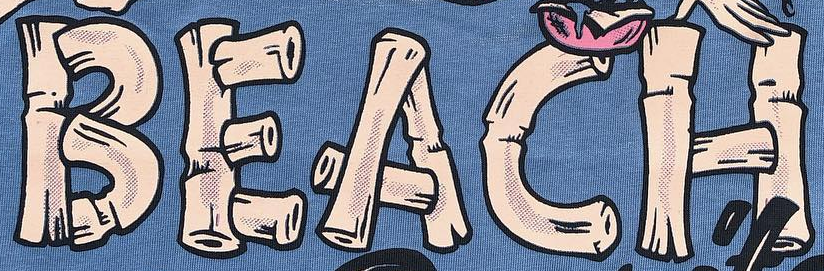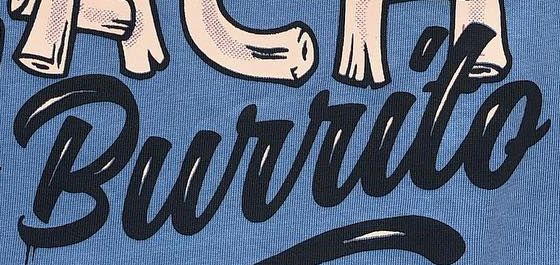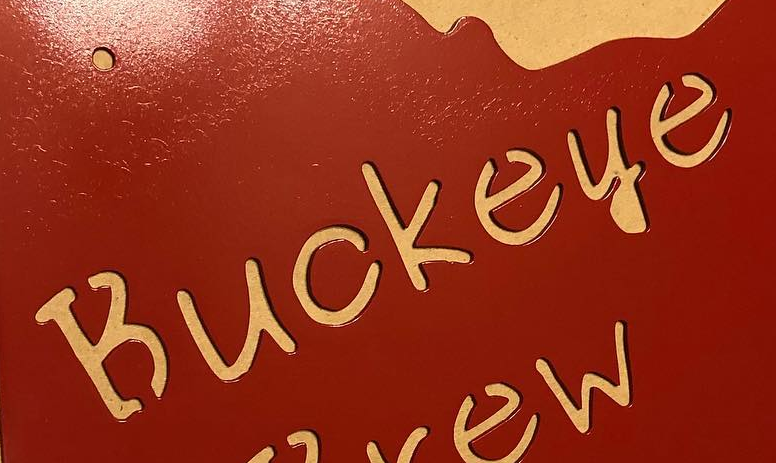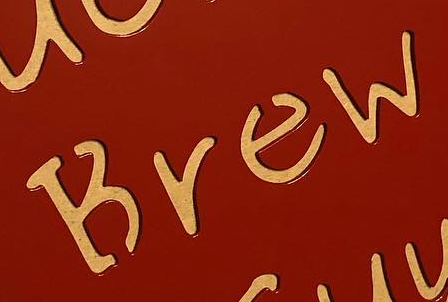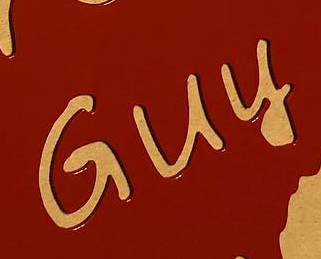Identify the words shown in these images in order, separated by a semicolon. BEACH; Burrito; Buckeye; Brew; Guy 